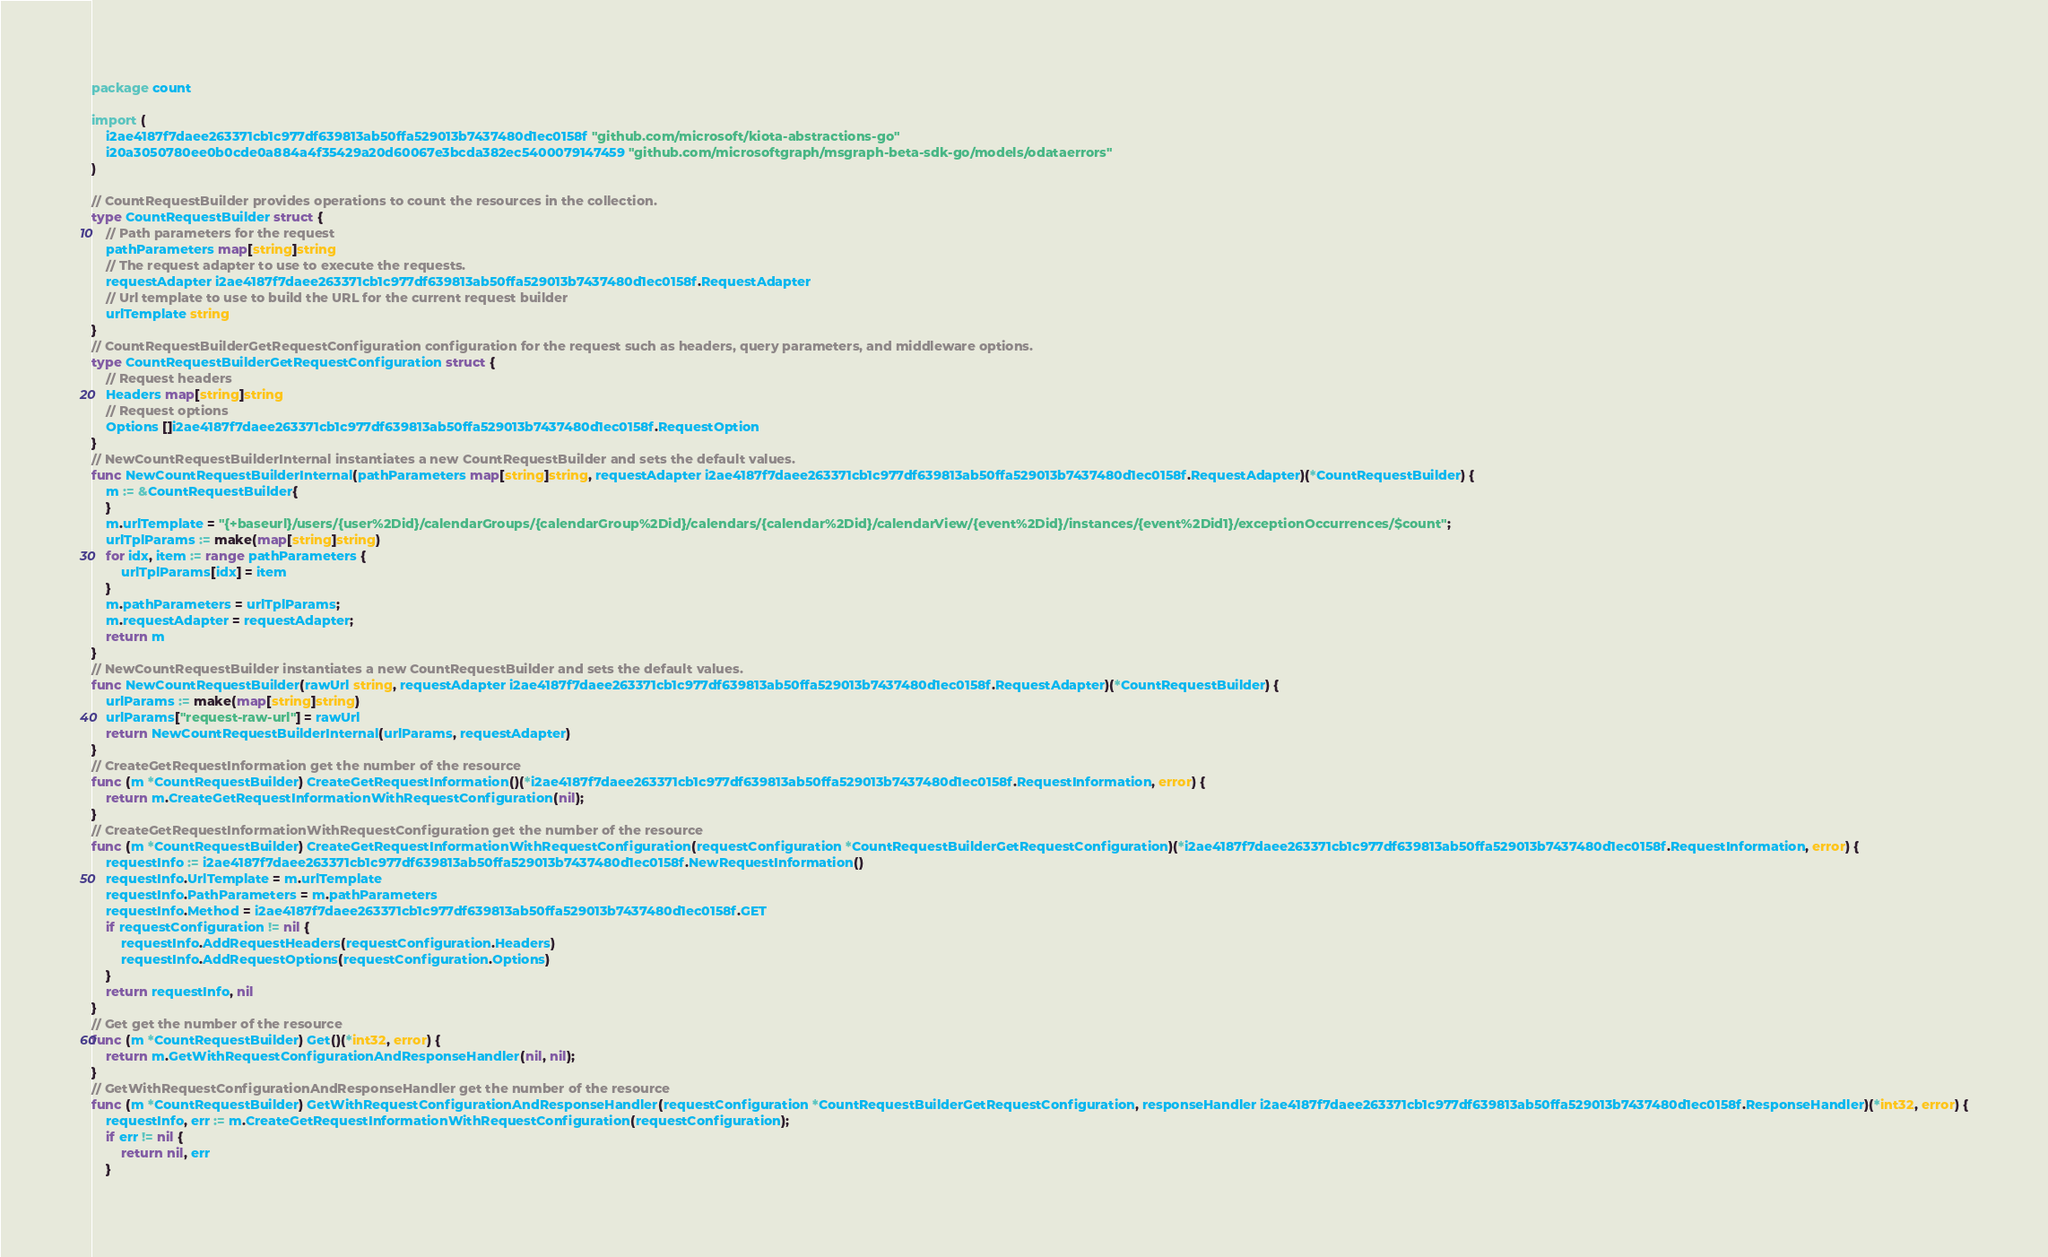<code> <loc_0><loc_0><loc_500><loc_500><_Go_>package count

import (
    i2ae4187f7daee263371cb1c977df639813ab50ffa529013b7437480d1ec0158f "github.com/microsoft/kiota-abstractions-go"
    i20a3050780ee0b0cde0a884a4f35429a20d60067e3bcda382ec5400079147459 "github.com/microsoftgraph/msgraph-beta-sdk-go/models/odataerrors"
)

// CountRequestBuilder provides operations to count the resources in the collection.
type CountRequestBuilder struct {
    // Path parameters for the request
    pathParameters map[string]string
    // The request adapter to use to execute the requests.
    requestAdapter i2ae4187f7daee263371cb1c977df639813ab50ffa529013b7437480d1ec0158f.RequestAdapter
    // Url template to use to build the URL for the current request builder
    urlTemplate string
}
// CountRequestBuilderGetRequestConfiguration configuration for the request such as headers, query parameters, and middleware options.
type CountRequestBuilderGetRequestConfiguration struct {
    // Request headers
    Headers map[string]string
    // Request options
    Options []i2ae4187f7daee263371cb1c977df639813ab50ffa529013b7437480d1ec0158f.RequestOption
}
// NewCountRequestBuilderInternal instantiates a new CountRequestBuilder and sets the default values.
func NewCountRequestBuilderInternal(pathParameters map[string]string, requestAdapter i2ae4187f7daee263371cb1c977df639813ab50ffa529013b7437480d1ec0158f.RequestAdapter)(*CountRequestBuilder) {
    m := &CountRequestBuilder{
    }
    m.urlTemplate = "{+baseurl}/users/{user%2Did}/calendarGroups/{calendarGroup%2Did}/calendars/{calendar%2Did}/calendarView/{event%2Did}/instances/{event%2Did1}/exceptionOccurrences/$count";
    urlTplParams := make(map[string]string)
    for idx, item := range pathParameters {
        urlTplParams[idx] = item
    }
    m.pathParameters = urlTplParams;
    m.requestAdapter = requestAdapter;
    return m
}
// NewCountRequestBuilder instantiates a new CountRequestBuilder and sets the default values.
func NewCountRequestBuilder(rawUrl string, requestAdapter i2ae4187f7daee263371cb1c977df639813ab50ffa529013b7437480d1ec0158f.RequestAdapter)(*CountRequestBuilder) {
    urlParams := make(map[string]string)
    urlParams["request-raw-url"] = rawUrl
    return NewCountRequestBuilderInternal(urlParams, requestAdapter)
}
// CreateGetRequestInformation get the number of the resource
func (m *CountRequestBuilder) CreateGetRequestInformation()(*i2ae4187f7daee263371cb1c977df639813ab50ffa529013b7437480d1ec0158f.RequestInformation, error) {
    return m.CreateGetRequestInformationWithRequestConfiguration(nil);
}
// CreateGetRequestInformationWithRequestConfiguration get the number of the resource
func (m *CountRequestBuilder) CreateGetRequestInformationWithRequestConfiguration(requestConfiguration *CountRequestBuilderGetRequestConfiguration)(*i2ae4187f7daee263371cb1c977df639813ab50ffa529013b7437480d1ec0158f.RequestInformation, error) {
    requestInfo := i2ae4187f7daee263371cb1c977df639813ab50ffa529013b7437480d1ec0158f.NewRequestInformation()
    requestInfo.UrlTemplate = m.urlTemplate
    requestInfo.PathParameters = m.pathParameters
    requestInfo.Method = i2ae4187f7daee263371cb1c977df639813ab50ffa529013b7437480d1ec0158f.GET
    if requestConfiguration != nil {
        requestInfo.AddRequestHeaders(requestConfiguration.Headers)
        requestInfo.AddRequestOptions(requestConfiguration.Options)
    }
    return requestInfo, nil
}
// Get get the number of the resource
func (m *CountRequestBuilder) Get()(*int32, error) {
    return m.GetWithRequestConfigurationAndResponseHandler(nil, nil);
}
// GetWithRequestConfigurationAndResponseHandler get the number of the resource
func (m *CountRequestBuilder) GetWithRequestConfigurationAndResponseHandler(requestConfiguration *CountRequestBuilderGetRequestConfiguration, responseHandler i2ae4187f7daee263371cb1c977df639813ab50ffa529013b7437480d1ec0158f.ResponseHandler)(*int32, error) {
    requestInfo, err := m.CreateGetRequestInformationWithRequestConfiguration(requestConfiguration);
    if err != nil {
        return nil, err
    }</code> 